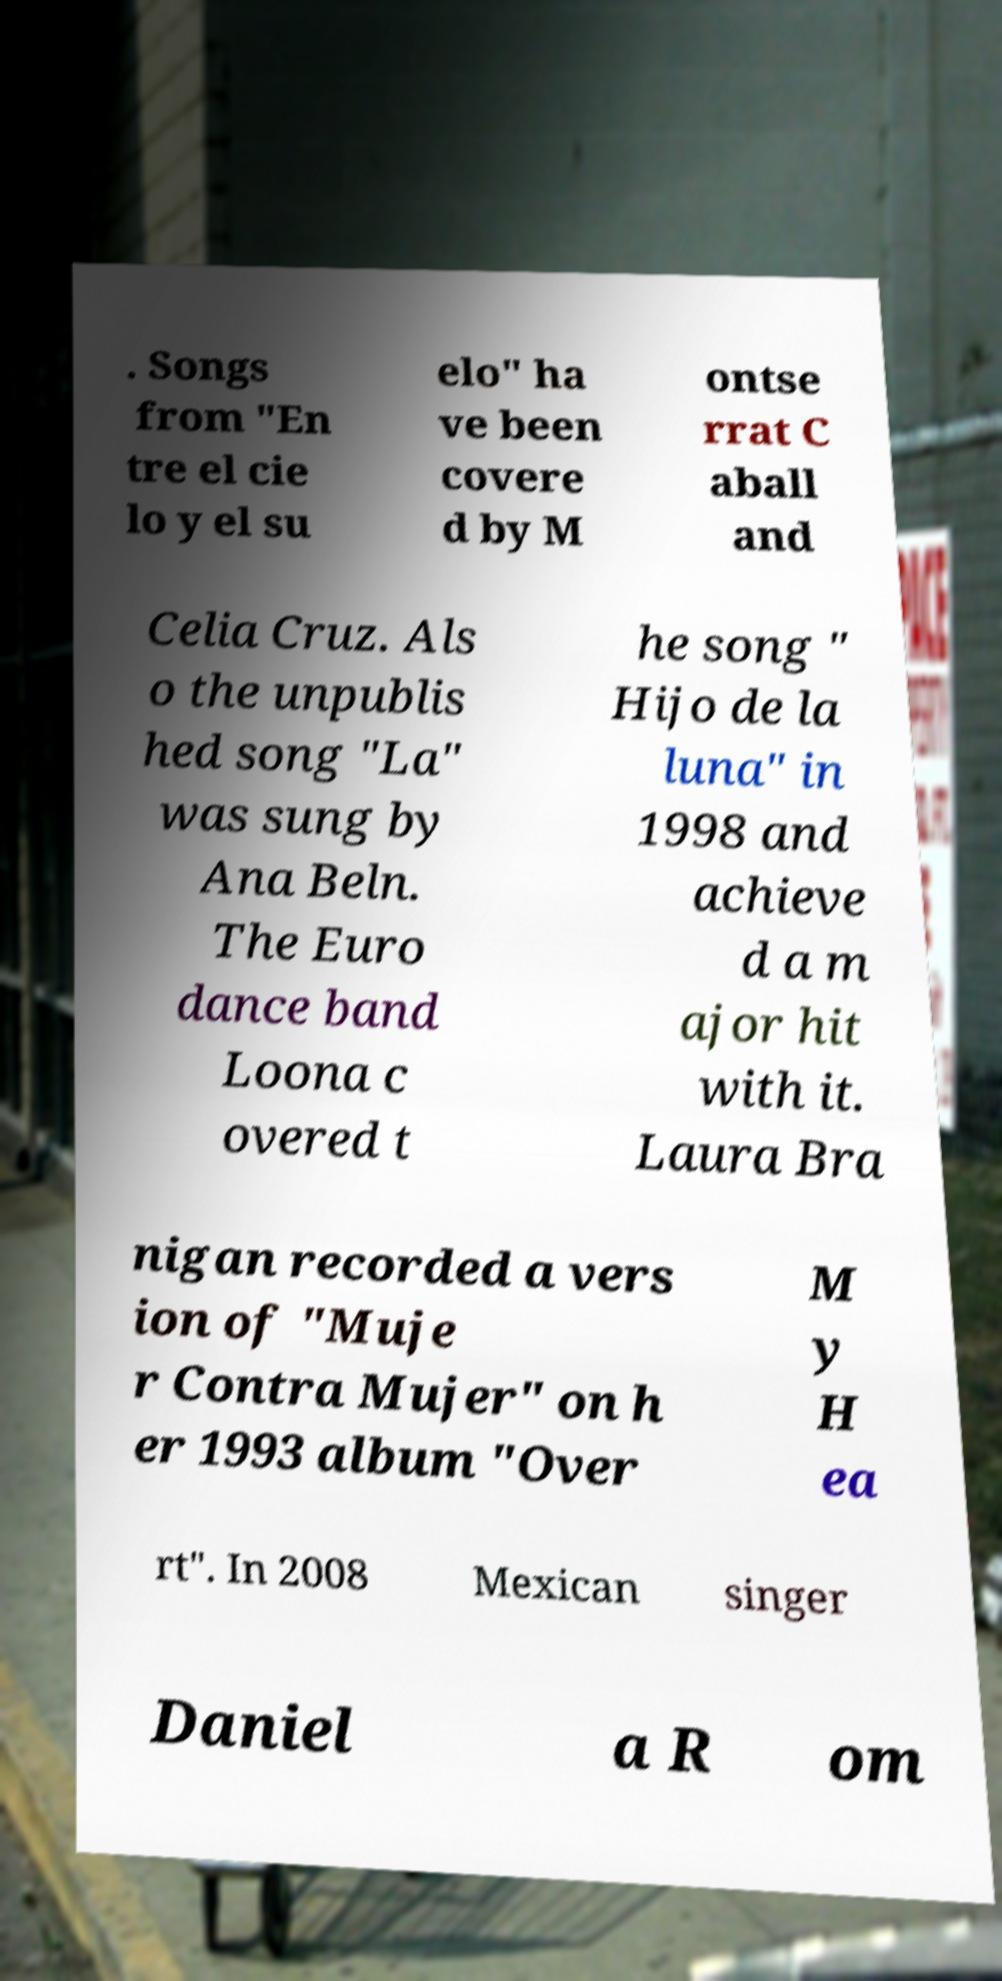For documentation purposes, I need the text within this image transcribed. Could you provide that? . Songs from "En tre el cie lo y el su elo" ha ve been covere d by M ontse rrat C aball and Celia Cruz. Als o the unpublis hed song "La" was sung by Ana Beln. The Euro dance band Loona c overed t he song " Hijo de la luna" in 1998 and achieve d a m ajor hit with it. Laura Bra nigan recorded a vers ion of "Muje r Contra Mujer" on h er 1993 album "Over M y H ea rt". In 2008 Mexican singer Daniel a R om 